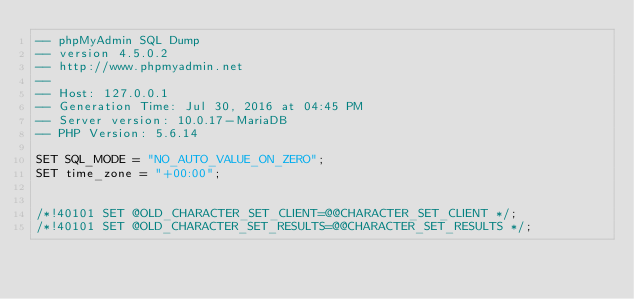<code> <loc_0><loc_0><loc_500><loc_500><_SQL_>-- phpMyAdmin SQL Dump
-- version 4.5.0.2
-- http://www.phpmyadmin.net
--
-- Host: 127.0.0.1
-- Generation Time: Jul 30, 2016 at 04:45 PM
-- Server version: 10.0.17-MariaDB
-- PHP Version: 5.6.14

SET SQL_MODE = "NO_AUTO_VALUE_ON_ZERO";
SET time_zone = "+00:00";


/*!40101 SET @OLD_CHARACTER_SET_CLIENT=@@CHARACTER_SET_CLIENT */;
/*!40101 SET @OLD_CHARACTER_SET_RESULTS=@@CHARACTER_SET_RESULTS */;</code> 